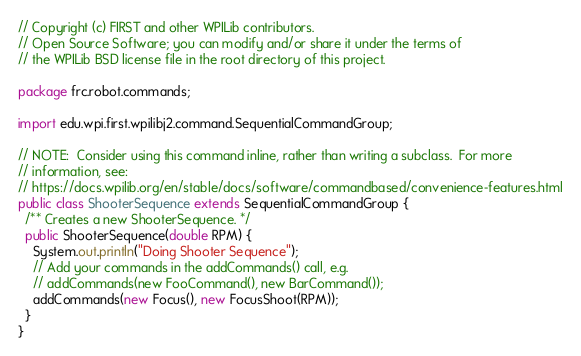<code> <loc_0><loc_0><loc_500><loc_500><_Java_>// Copyright (c) FIRST and other WPILib contributors.
// Open Source Software; you can modify and/or share it under the terms of
// the WPILib BSD license file in the root directory of this project.

package frc.robot.commands;

import edu.wpi.first.wpilibj2.command.SequentialCommandGroup;

// NOTE:  Consider using this command inline, rather than writing a subclass.  For more
// information, see:
// https://docs.wpilib.org/en/stable/docs/software/commandbased/convenience-features.html
public class ShooterSequence extends SequentialCommandGroup {
  /** Creates a new ShooterSequence. */
  public ShooterSequence(double RPM) {
    System.out.println("Doing Shooter Sequence");
    // Add your commands in the addCommands() call, e.g.
    // addCommands(new FooCommand(), new BarCommand());
    addCommands(new Focus(), new FocusShoot(RPM));
  }
}
</code> 